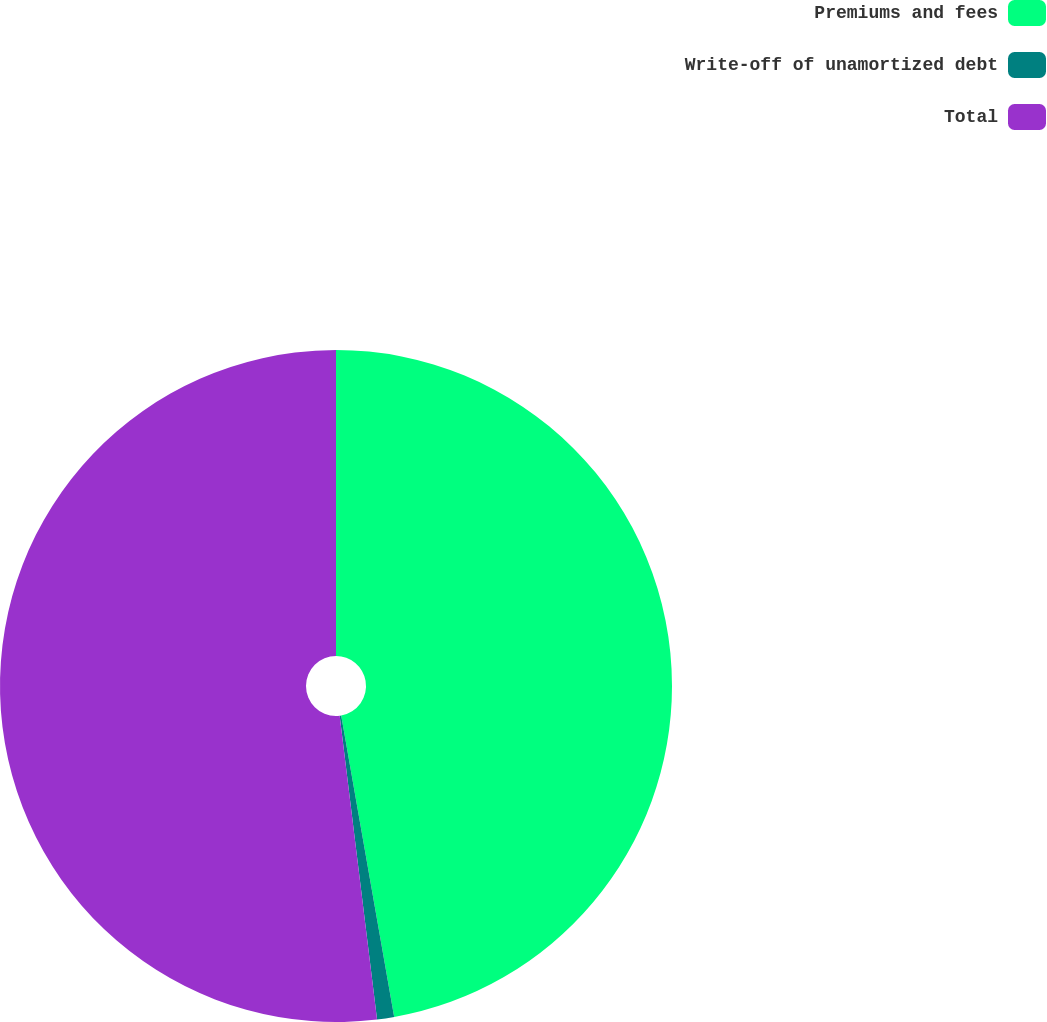Convert chart. <chart><loc_0><loc_0><loc_500><loc_500><pie_chart><fcel>Premiums and fees<fcel>Write-off of unamortized debt<fcel>Total<nl><fcel>47.23%<fcel>0.82%<fcel>51.95%<nl></chart> 